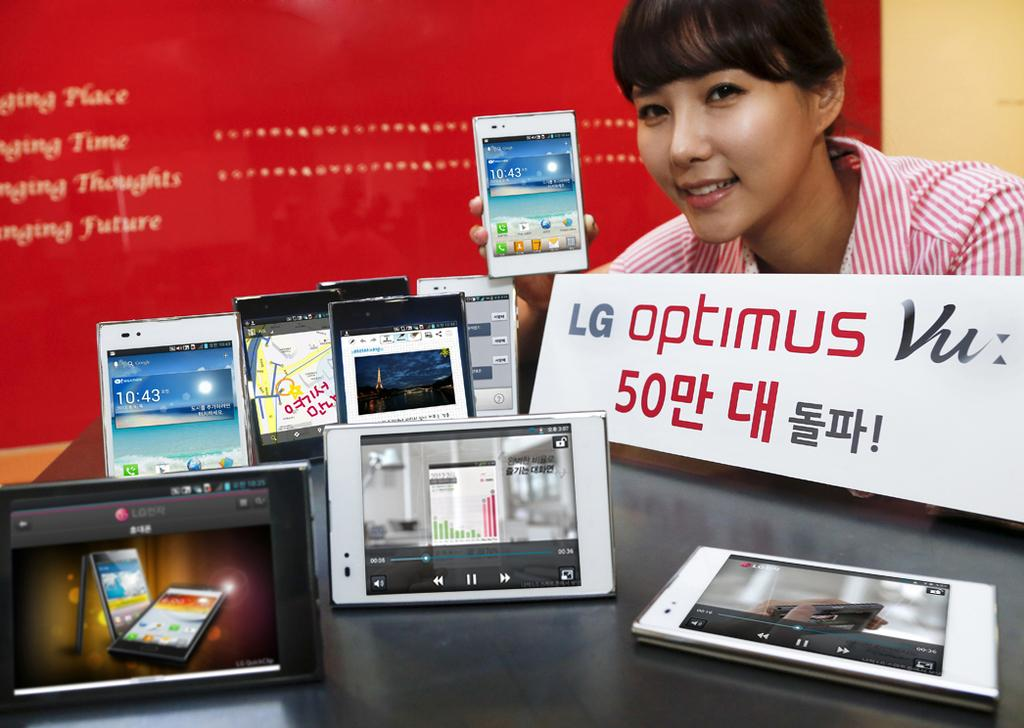What can be seen in the image in large quantities? There are many mobiles in the image. What else is present in the image besides mobiles? There is a board, a person holding a mobile, and a banner in the background of the image. How is the person holding the mobile depicted? The person is smiling. What type of stitch is being used to sew the ball in the image? There is no ball present in the image, so it is not possible to determine the type of stitch being used. 